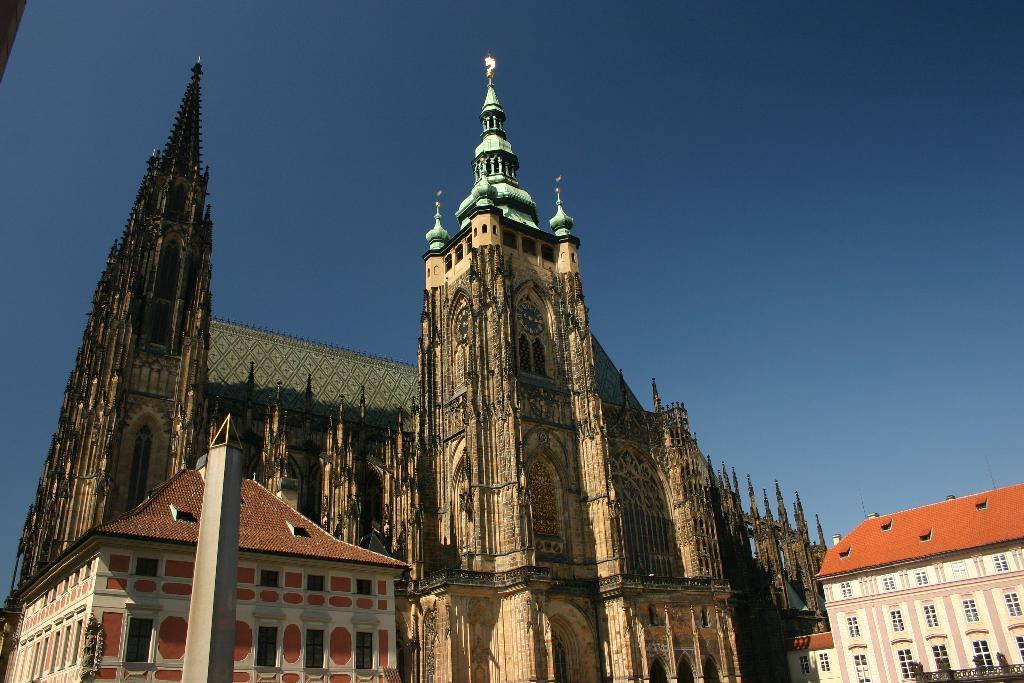What type of structures can be seen in the image? There are buildings in the image. What type of fuel is being used by the buildings in the image? There is no information provided about the type of fuel being used by the buildings in the image. What border is visible in the image? There is no border visible in the image; it only shows buildings. 